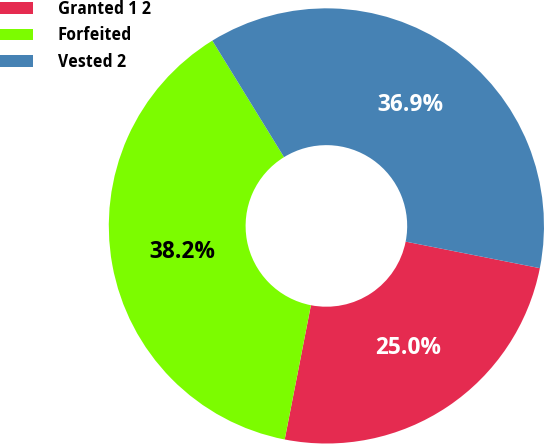Convert chart. <chart><loc_0><loc_0><loc_500><loc_500><pie_chart><fcel>Granted 1 2<fcel>Forfeited<fcel>Vested 2<nl><fcel>24.96%<fcel>38.15%<fcel>36.89%<nl></chart> 